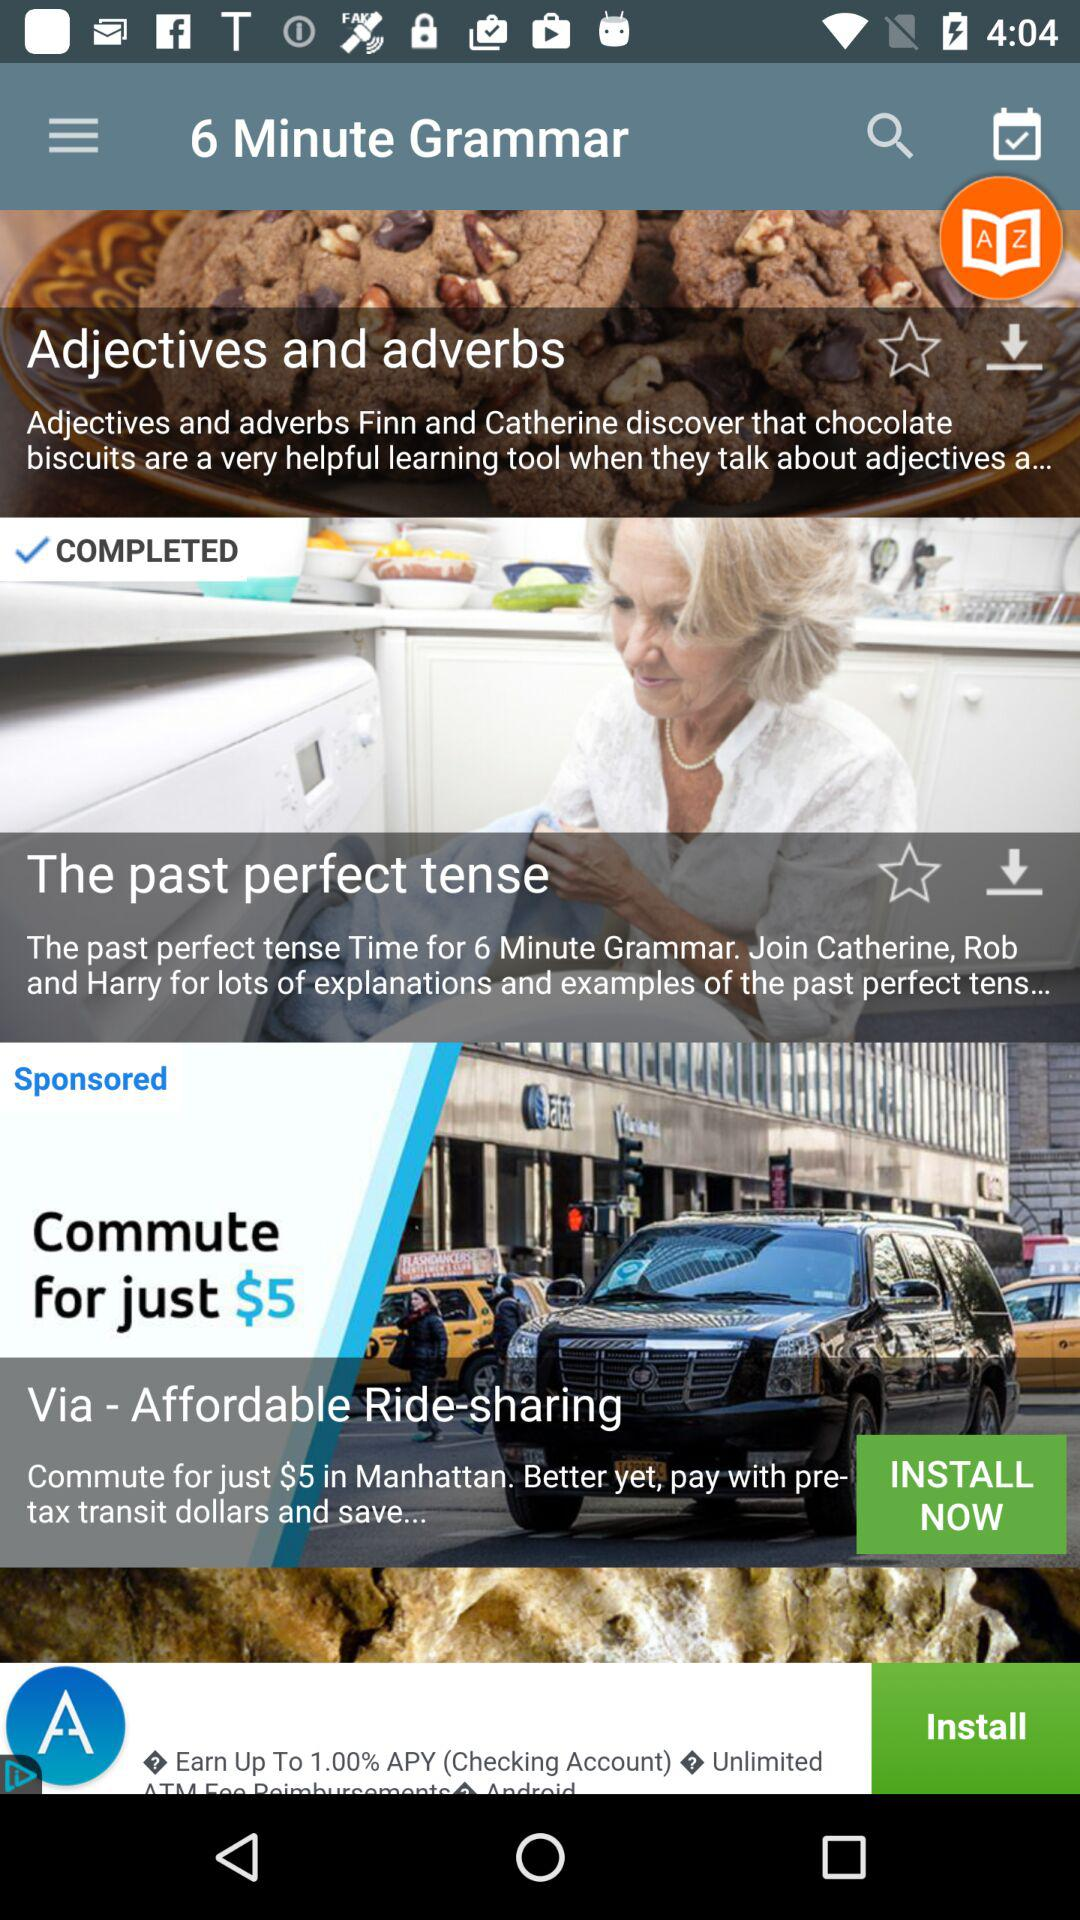How many items are sponsored?
Answer the question using a single word or phrase. 1 